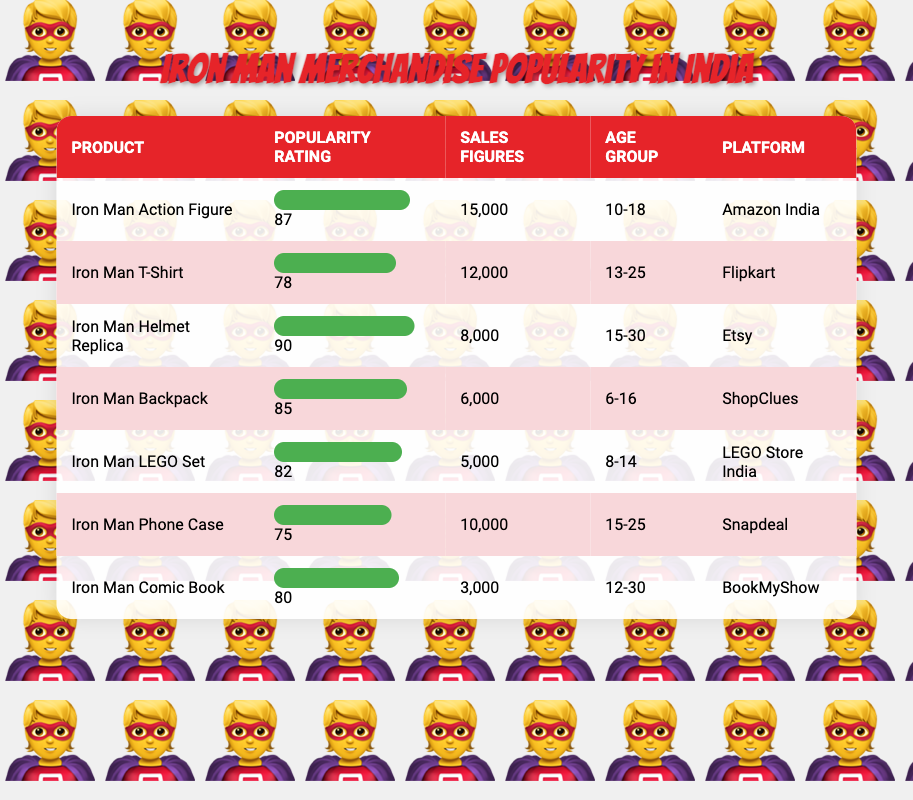What is the most popular Iron Man merchandise according to the table? The most popular product is the "Iron Man Helmet Replica," which has a popularity rating of 90.
Answer: Iron Man Helmet Replica Which product has the lowest sales figures? The product with the lowest sales figures is the "Iron Man Comic Book," with sales of 3,000 units.
Answer: Iron Man Comic Book Is the Iron Man T-Shirt more popular than the Iron Man Phone Case? The Iron Man T-Shirt has a popularity rating of 78, while the Iron Man Phone Case has a rating of 75, indicating that the T-Shirt is indeed more popular.
Answer: Yes What is the total sales figure for Iron Man merchandise targeted at the age group 15-25? The age group 15-25 includes two products: Iron Man Helmet Replica (8,000) and Iron Man Phone Case (10,000). Adding these gives: 8,000 + 10,000 = 18,000.
Answer: 18,000 How many products have a popularity rating above 80? The products with ratings above 80 are: Iron Man Action Figure (87), Iron Man Helmet Replica (90), Iron Man Backpack (85), and Iron Man LEGO Set (82). This amounts to four products.
Answer: 4 Which platform sells the Iron Man Backpack? The Iron Man Backpack is sold on "ShopClues".
Answer: ShopClues Is the Iron Man Action Figure more popular among younger people than the Iron Man Comic Book? The Iron Man Action Figure targets the age group 10-18 with a popularity rating of 87, while the Iron Man Comic Book targets 12-30 with a rating of 80. Given the ratings, it is more popular among younger people.
Answer: Yes What is the average popularity rating of all Iron Man merchandise? The sum of popularity ratings is (87 + 78 + 90 + 85 + 82 + 75 + 80) = 577. Since there are 7 products, the average is 577 / 7 ≈ 82.43.
Answer: 82.43 